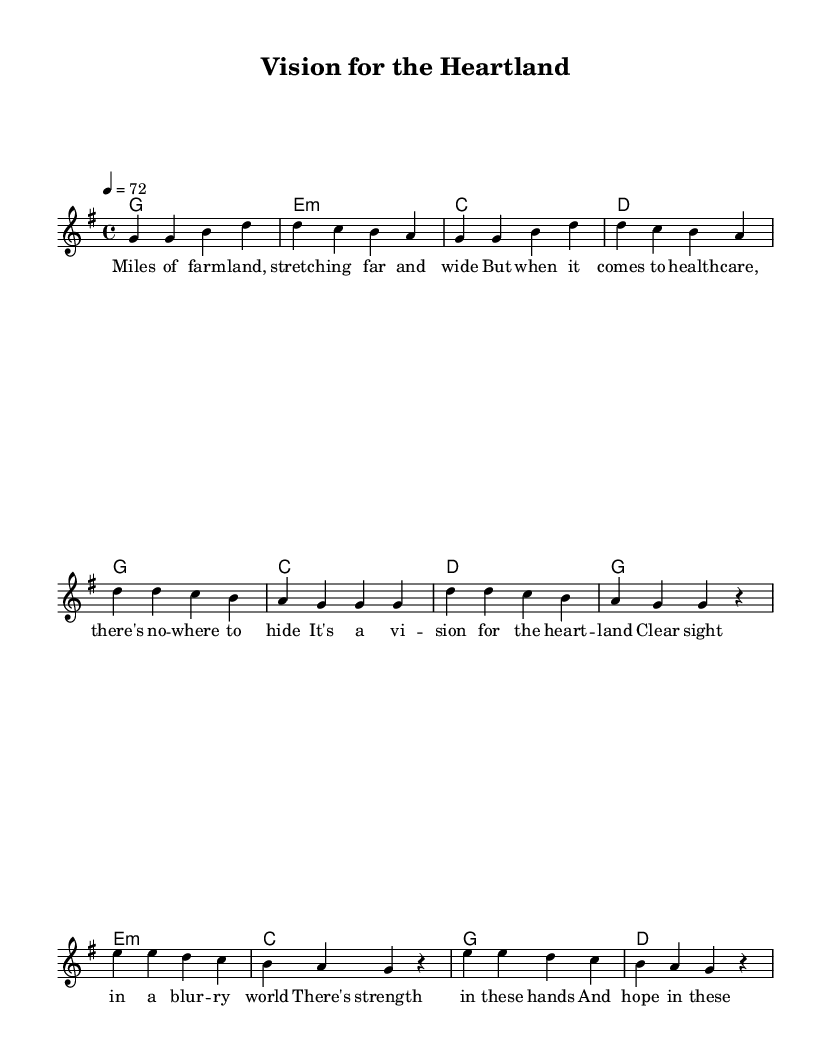What is the key signature of this music? The key signature is G major, which has one sharp (F#). This can be determined by looking at the beginning of the staff, where the key signature is indicated.
Answer: G major What is the time signature of the piece? The time signature is 4/4, which means there are four beats in each measure and a quarter note gets one beat. This is located next to the key signature at the beginning of the score.
Answer: 4/4 What is the tempo marking for this piece? The tempo marking is 72 beats per minute, indicated in the tempo directive at the beginning of the score. This specifies the speed at which the piece should be played.
Answer: 72 How many measures are there in the melody? The melody consists of 16 measures. By counting the number of vertical lines (bar lines) in the melody section, it can be concluded that there are 15 bar lines separating the measures, resulting in a total of 16 measures including the first measure.
Answer: 16 What is the primary theme of the lyrics? The primary theme of the lyrics focuses on the challenges of healthcare in rural areas, as suggested by phrases about land and vision for the heartland. The lyrics emphasize a longing for better healthcare access in these regions.
Answer: Challenges of rural healthcare What type of chords are used in the verse? The chords used in the verse are primarily major and minor chords: G, E minor, C, and D. This can be identified from the chord symbols listed in the harmonic section corresponding to each measure.
Answer: Major and minor chords What direction do the melody notes mostly move in during the chorus? The melody notes mostly descend during the chorus, particularly from D down to A. This can be observed by analyzing the pitch intervals between the notes in the chorus section that show a downward trend.
Answer: Descending 